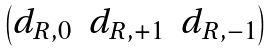<formula> <loc_0><loc_0><loc_500><loc_500>\begin{pmatrix} d _ { R , 0 } & d _ { R , + 1 } & d _ { R , - 1 } \end{pmatrix}</formula> 